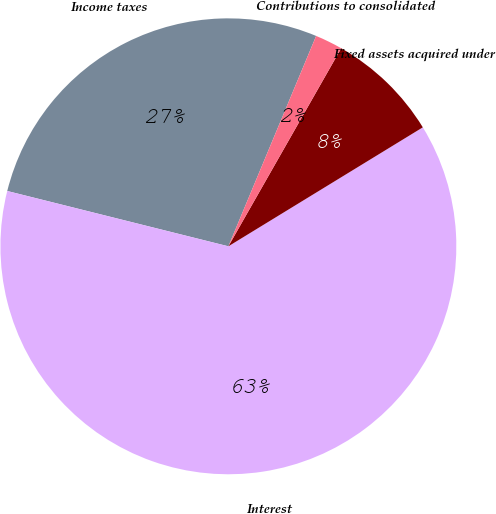Convert chart to OTSL. <chart><loc_0><loc_0><loc_500><loc_500><pie_chart><fcel>Income taxes<fcel>Interest<fcel>Fixed assets acquired under<fcel>Contributions to consolidated<nl><fcel>27.39%<fcel>62.64%<fcel>8.02%<fcel>1.95%<nl></chart> 